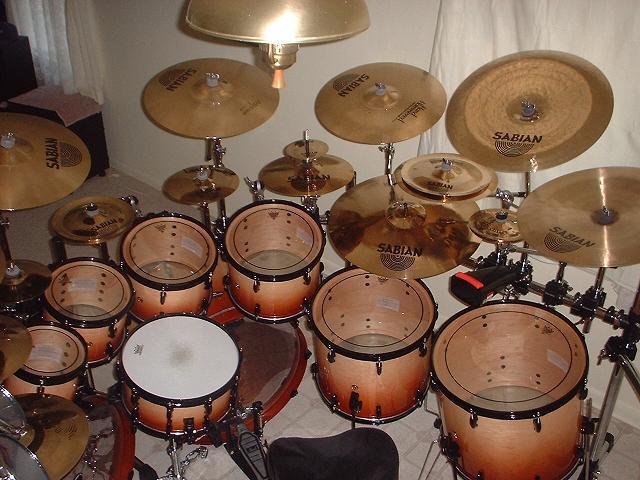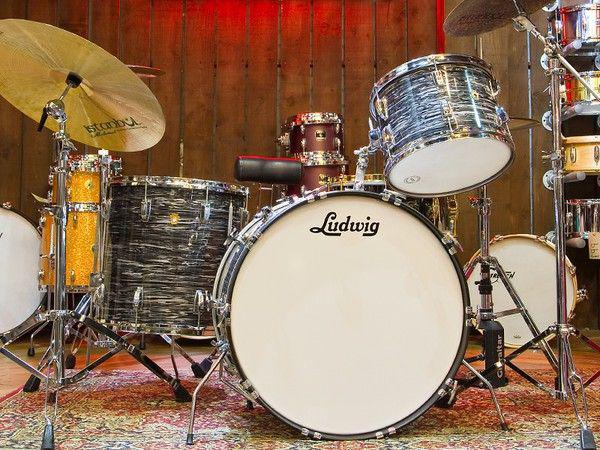The first image is the image on the left, the second image is the image on the right. Considering the images on both sides, is "The right image shows a row of at least three white-topped drums with black around at least part of their sides and no cymbals." valid? Answer yes or no. No. 